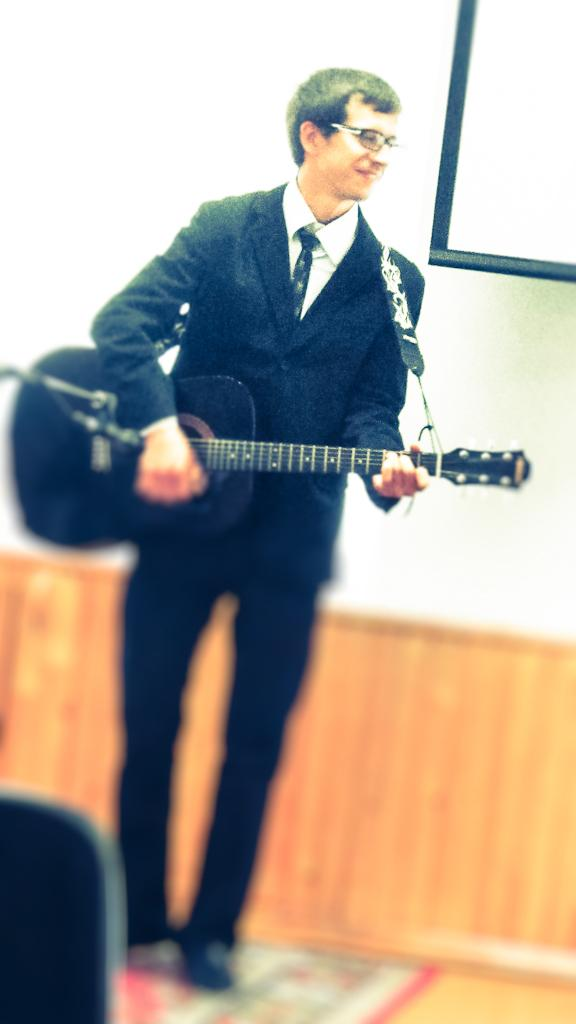Where was the image taken? The image was taken in a room. What is the boy in the image wearing? The boy is wearing a black blazer. What is the boy holding in the image? The boy is holding a guitar. Who else is present in the image besides the boy? There is a man standing in the image. What is the man standing on? The man is standing on the floor. What is behind the man in the image? There is a wall and a projector screen behind the man. What type of flame can be seen coming from the guitar in the image? There is no flame coming from the guitar in the image; it is a regular guitar being held by the boy. 